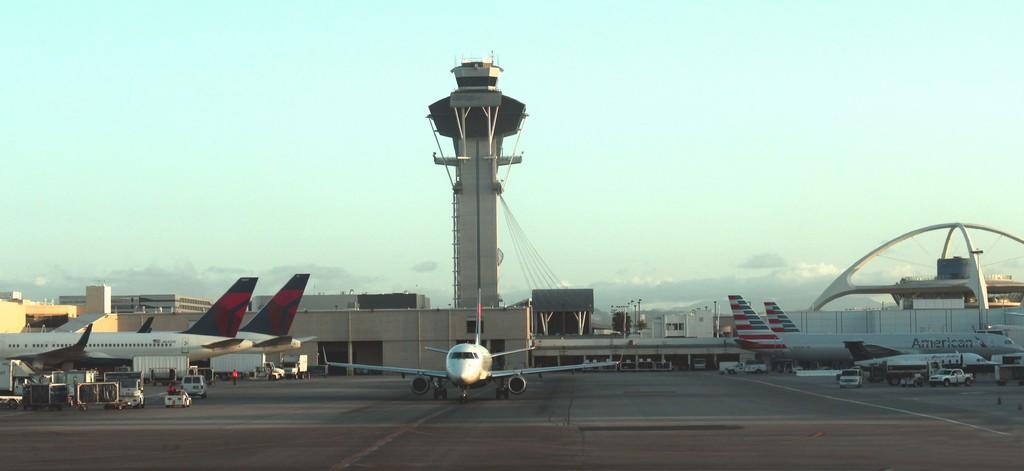What type of structures can be seen in the image? There are buildings and a tower in the image. Are there any architectural features present in the image? Yes, there are arches in the image. What type of transportation is visible in the image? There are planes and vehicles in the image. Can you describe the people in the image? There are people in the image. What is the weather like in the image? The sky is cloudy in the image. What else can be seen in the image? There are poles in the image. What type of bed can be seen in the image? There is no bed present in the image. What is the cork used for in the image? There is no cork present in the image. 